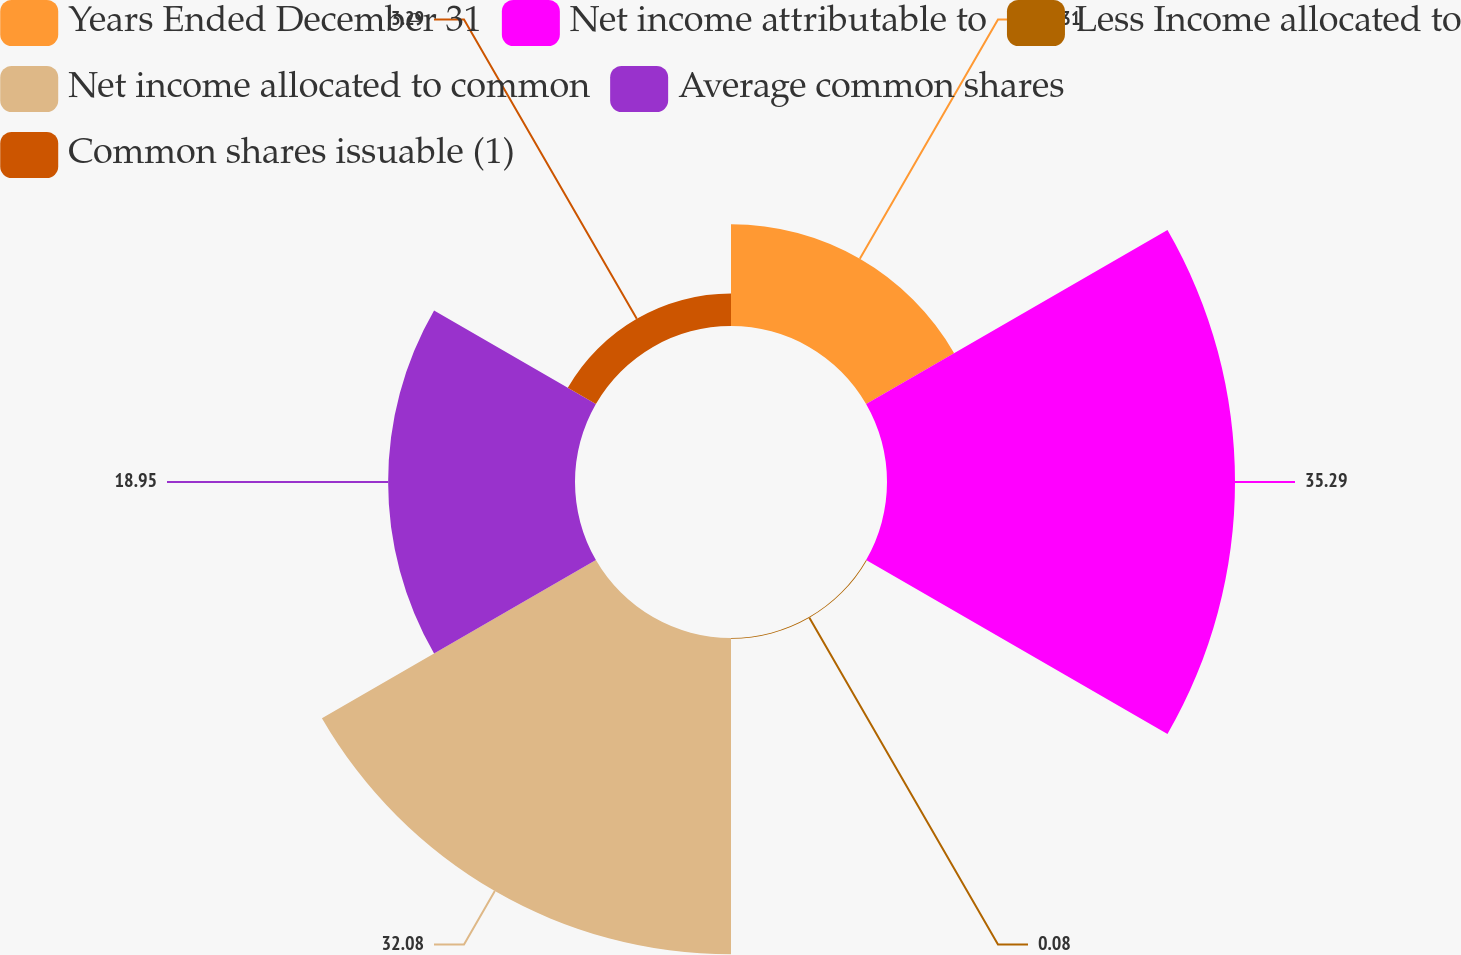<chart> <loc_0><loc_0><loc_500><loc_500><pie_chart><fcel>Years Ended December 31<fcel>Net income attributable to<fcel>Less Income allocated to<fcel>Net income allocated to common<fcel>Average common shares<fcel>Common shares issuable (1)<nl><fcel>10.31%<fcel>35.29%<fcel>0.08%<fcel>32.08%<fcel>18.95%<fcel>3.29%<nl></chart> 